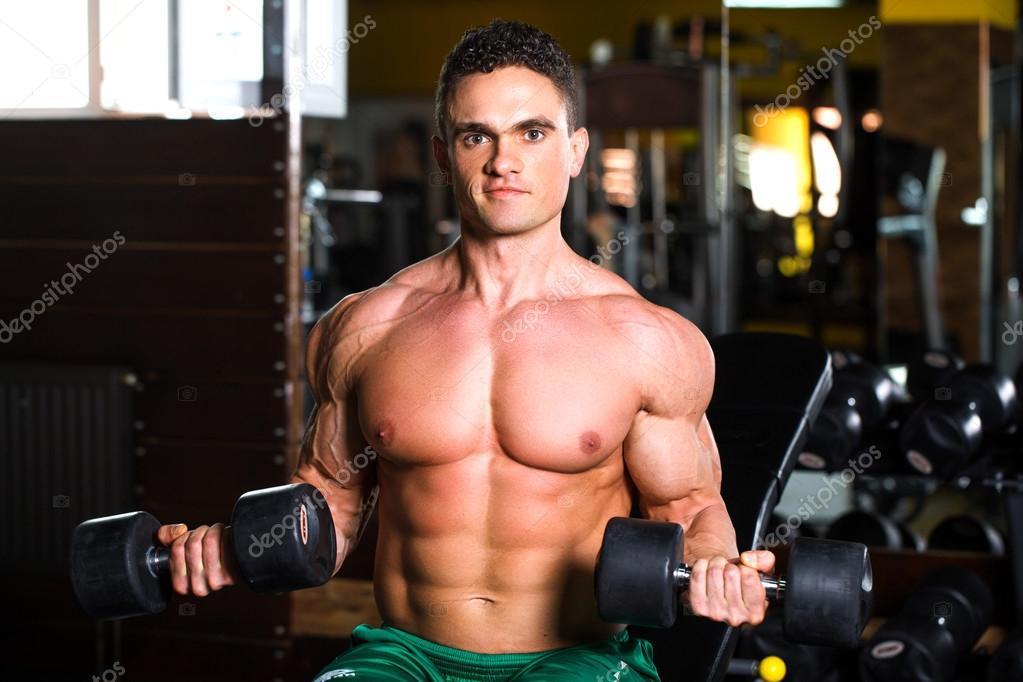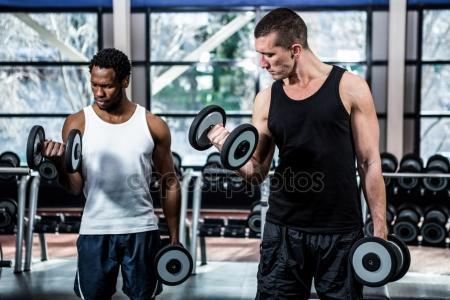The first image is the image on the left, the second image is the image on the right. For the images shown, is this caption "The front of a male torso is facing toward the camera in the left image." true? Answer yes or no. Yes. 